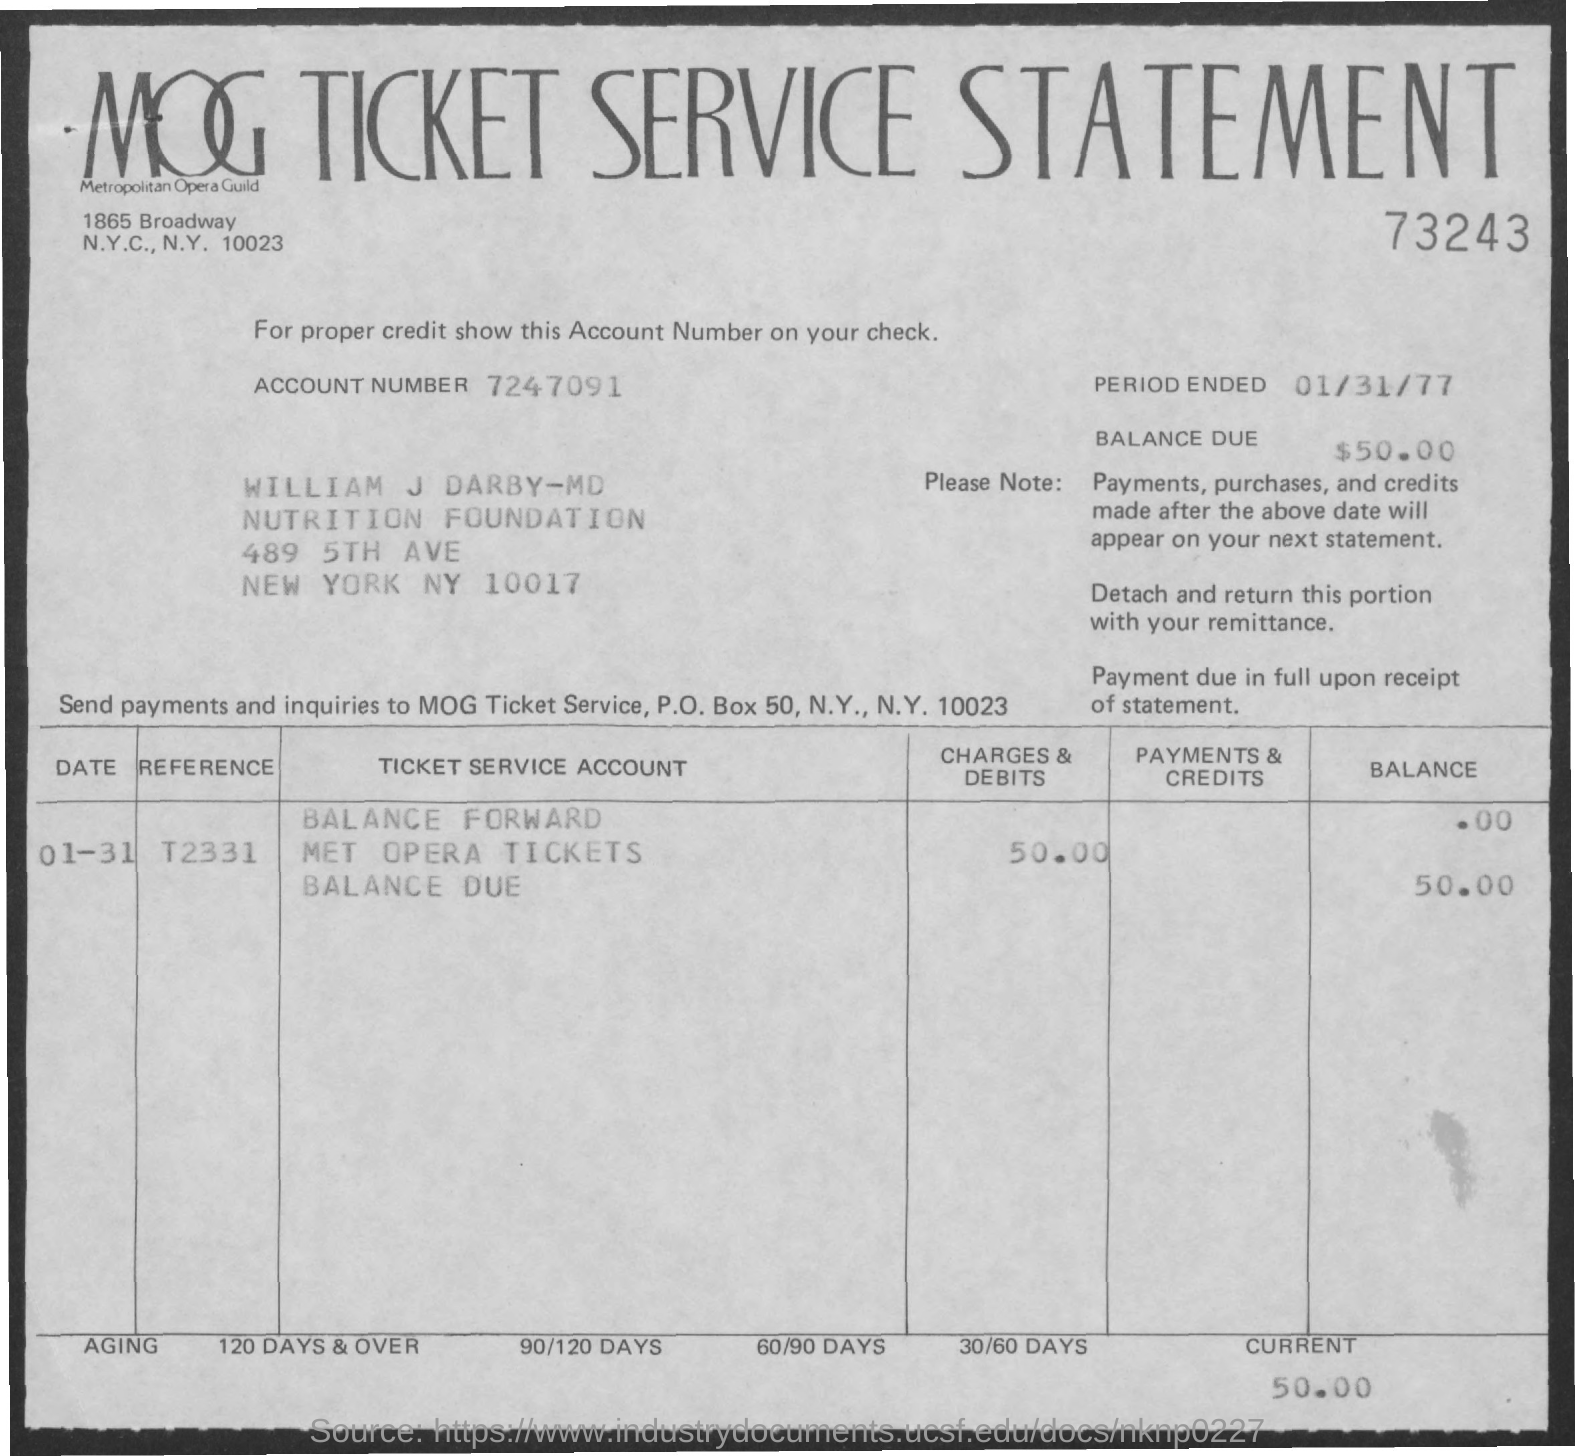Indicate a few pertinent items in this graphic. The current balance is 50.00. The MOG Ticket Service Statement is the title of a document. The end period is January 31st, 1977. The number that is written directly below the title is 73243... The account number is 7247091... 